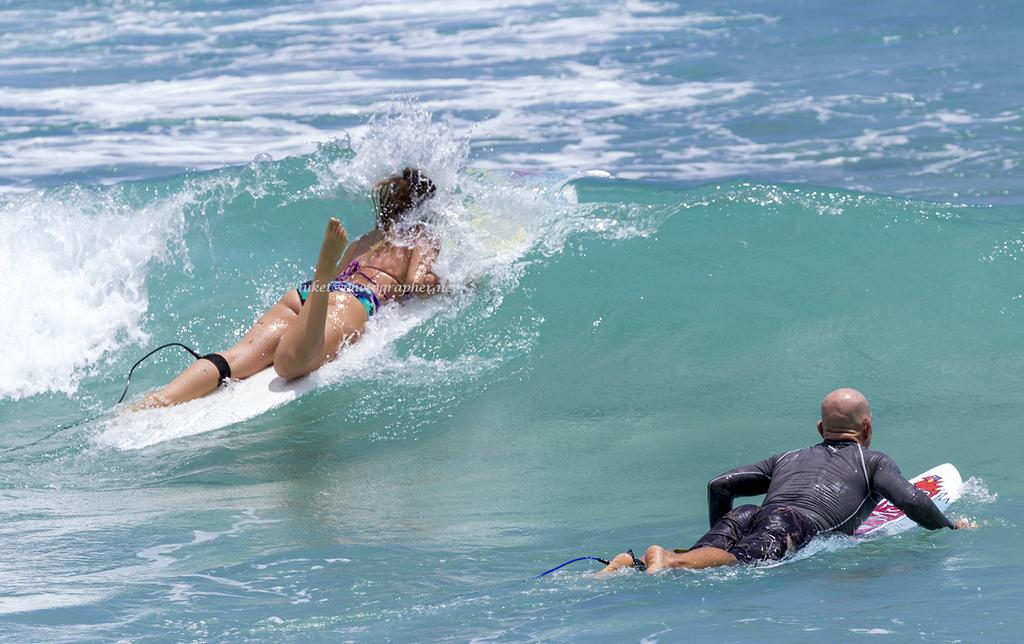What is visible in the image? There is water visible in the image. How many people are in the image? There are two people in the image. What are the two people doing in the image? The two people are laying on surfing boards. What type of glue is being used to hold the plantation together in the image? There is no glue or plantation present in the image; it features water and two people on surfing boards. 